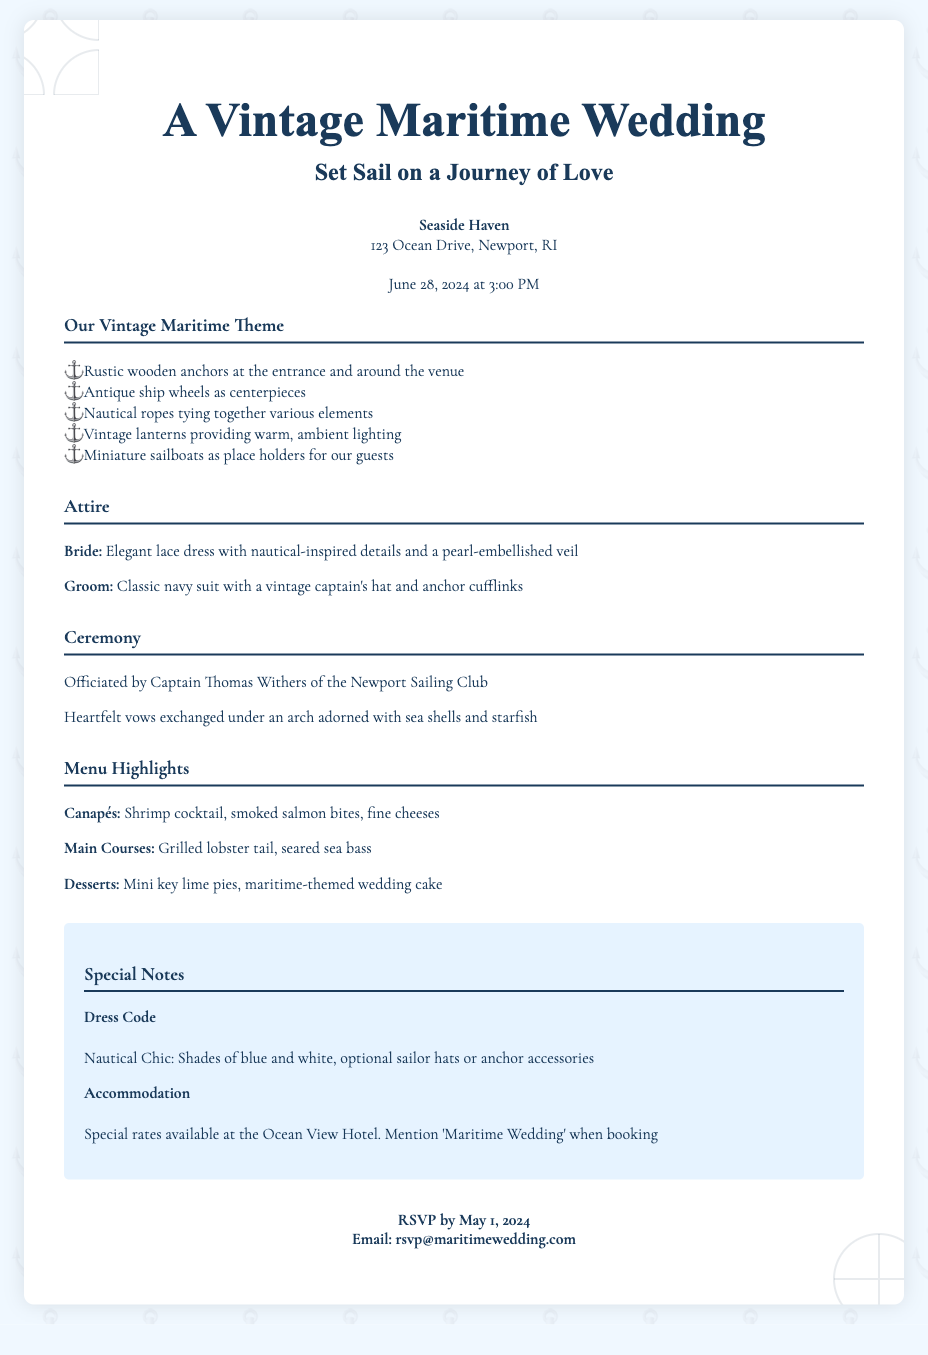What is the venue for the wedding? The venue is mentioned in the document as "Seaside Haven."
Answer: Seaside Haven What is the date and time of the wedding? The date and time are stated in the document as "June 28, 2024 at 3:00 PM."
Answer: June 28, 2024 at 3:00 PM Who is officiating the ceremony? The document states that the ceremony is officiated by "Captain Thomas Withers."
Answer: Captain Thomas Withers What is the dress code specified in the special notes? The document lists the dress code as "Nautical Chic."
Answer: Nautical Chic What kind of decorations are used at the venue? The document describes several types of decorations including rustic wooden anchors.
Answer: rustic wooden anchors What is one of the menu highlights for desserts? The dessert mentioned in the document is "mini key lime pies."
Answer: mini key lime pies What should guests mention when booking accommodation? The document states guests should mention "'Maritime Wedding.'"
Answer: 'Maritime Wedding' What items are the centerpieces of the tables? The document specifies that "antique ship wheels" are used as centerpieces.
Answer: antique ship wheels 